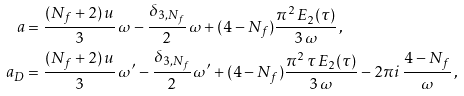<formula> <loc_0><loc_0><loc_500><loc_500>a & = \frac { ( N _ { f } + 2 ) \, u } { 3 } \, \omega - \frac { \delta _ { 3 , N _ { f } } } { 2 } \, \omega + ( 4 - N _ { f } ) \frac { \pi ^ { 2 } \, E _ { 2 } ( \tau ) } { 3 \, \omega } \, , \\ a _ { D } & = \frac { ( N _ { f } + 2 ) \, u } { 3 } \, \omega ^ { \prime } - \frac { \delta _ { 3 , N _ { f } } } { 2 } \, \omega ^ { \prime } + ( 4 - N _ { f } ) \frac { \pi ^ { 2 } \, \tau \, E _ { 2 } ( \tau ) } { 3 \, \omega } - 2 \pi i \, \frac { 4 - N _ { f } } { \omega } \, ,</formula> 